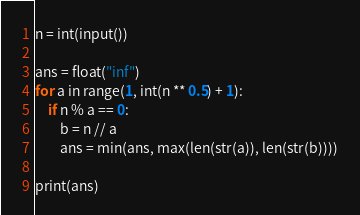Convert code to text. <code><loc_0><loc_0><loc_500><loc_500><_Python_>n = int(input())

ans = float("inf")
for a in range(1, int(n ** 0.5) + 1):
    if n % a == 0:
        b = n // a
        ans = min(ans, max(len(str(a)), len(str(b))))

print(ans)</code> 